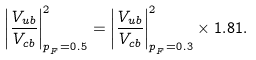<formula> <loc_0><loc_0><loc_500><loc_500>\left | \frac { V _ { u b } } { V _ { c b } } \right | ^ { 2 } _ { p _ { _ { F } } = 0 . 5 } = \left | \frac { V _ { u b } } { V _ { c b } } \right | ^ { 2 } _ { p _ { _ { F } } = 0 . 3 } \times 1 . 8 1 .</formula> 